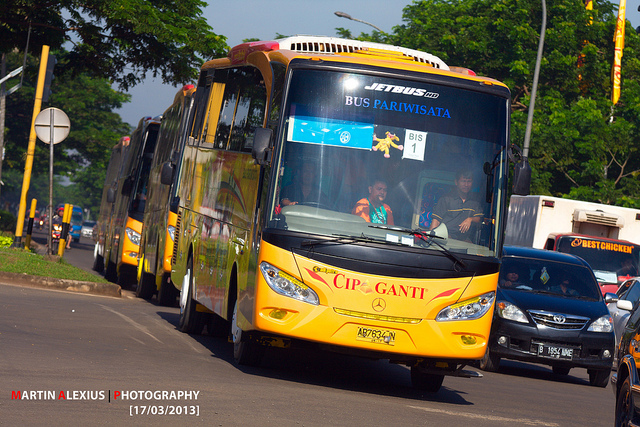What might a day in the life of the bus driver look like? A day in the life of the bus driver starts early in the morning, with a routine check of the bus to ensure it's in top condition. After a quick breakfast, the driver heads to the bus depot to start their route. The morning is filled with picking up excited tourists from various hotels and guiding them through the city’s landmarks. The driver has to navigate through traffic, answer passengers' questions, and ensure everyone’s safety. Lunchtime offers a brief respite before the afternoon tours resume. By evening, after the final drop-off, the driver winds down by cleaning the bus and preparing it for the next day’s journey. Despite the long hours, the driver finds joy in the smiles and gratitude of the tourists, making every day an adventure in itself. 